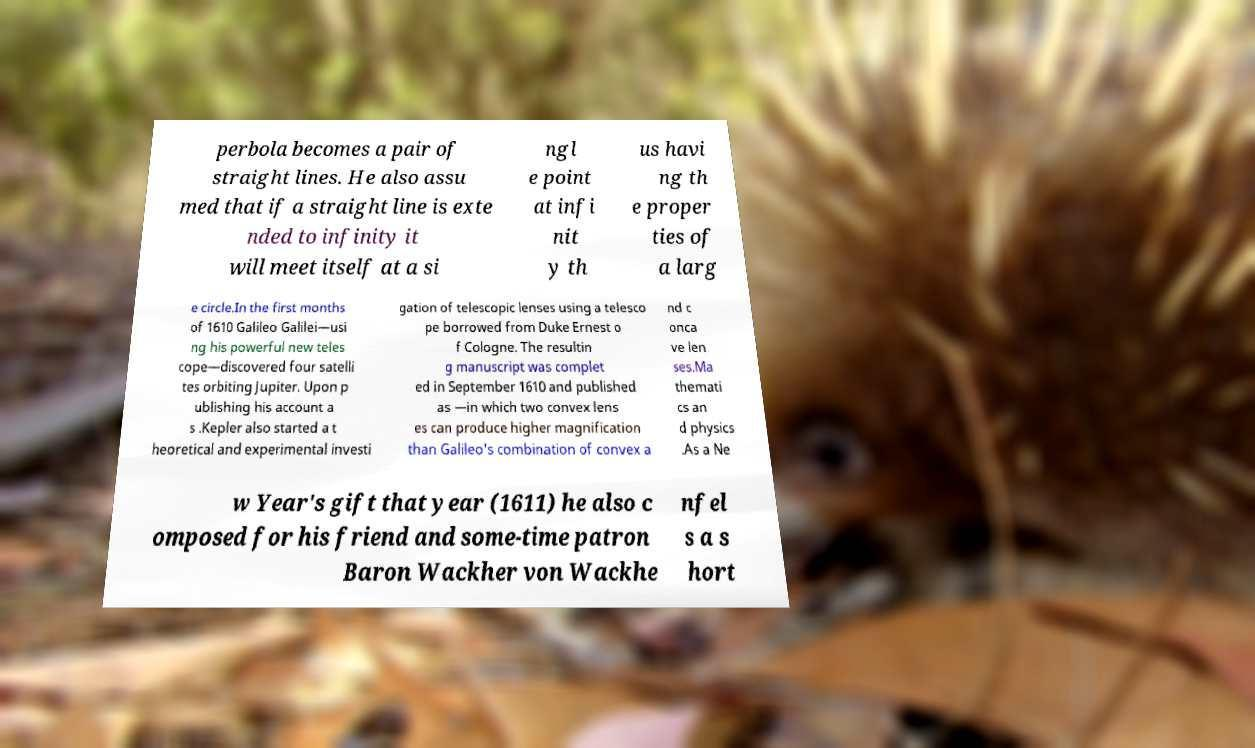For documentation purposes, I need the text within this image transcribed. Could you provide that? perbola becomes a pair of straight lines. He also assu med that if a straight line is exte nded to infinity it will meet itself at a si ngl e point at infi nit y th us havi ng th e proper ties of a larg e circle.In the first months of 1610 Galileo Galilei—usi ng his powerful new teles cope—discovered four satelli tes orbiting Jupiter. Upon p ublishing his account a s .Kepler also started a t heoretical and experimental investi gation of telescopic lenses using a telesco pe borrowed from Duke Ernest o f Cologne. The resultin g manuscript was complet ed in September 1610 and published as —in which two convex lens es can produce higher magnification than Galileo's combination of convex a nd c onca ve len ses.Ma themati cs an d physics .As a Ne w Year's gift that year (1611) he also c omposed for his friend and some-time patron Baron Wackher von Wackhe nfel s a s hort 